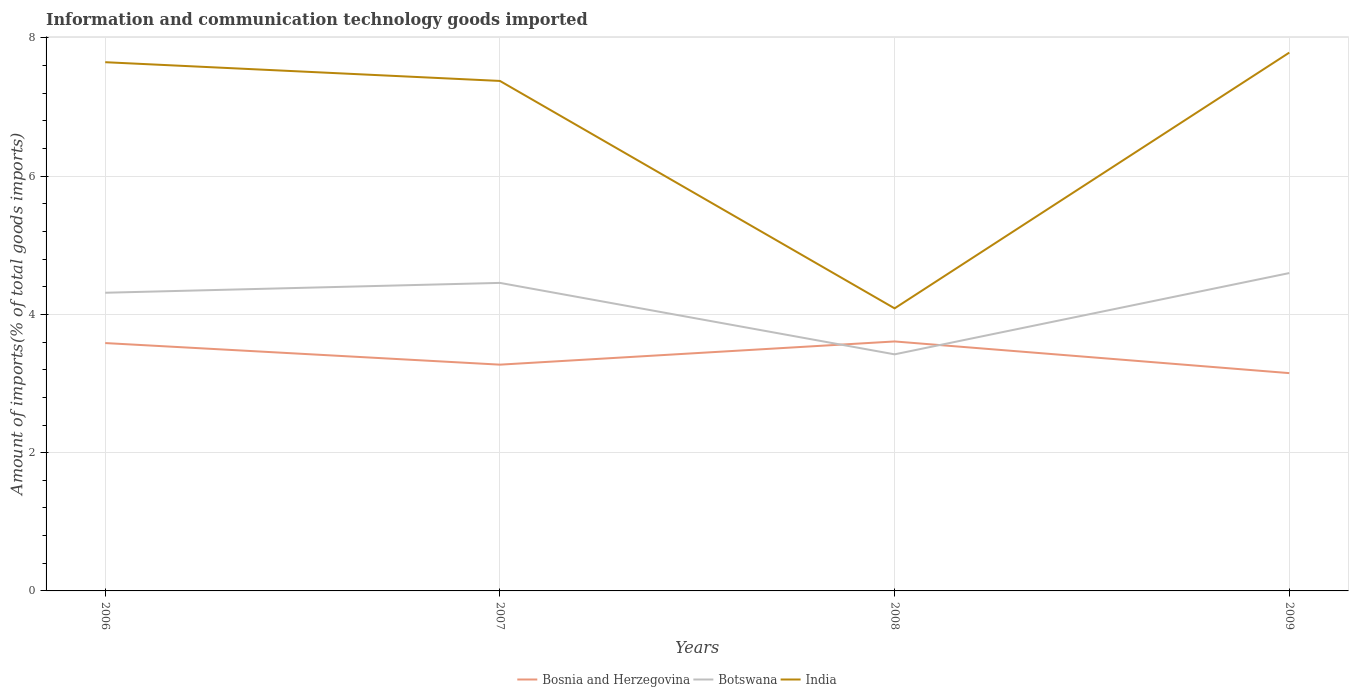How many different coloured lines are there?
Your response must be concise. 3. Is the number of lines equal to the number of legend labels?
Your answer should be compact. Yes. Across all years, what is the maximum amount of goods imported in India?
Ensure brevity in your answer.  4.09. What is the total amount of goods imported in India in the graph?
Make the answer very short. -0.14. What is the difference between the highest and the second highest amount of goods imported in Botswana?
Give a very brief answer. 1.18. Is the amount of goods imported in Botswana strictly greater than the amount of goods imported in Bosnia and Herzegovina over the years?
Make the answer very short. No. How many years are there in the graph?
Keep it short and to the point. 4. Are the values on the major ticks of Y-axis written in scientific E-notation?
Offer a very short reply. No. Does the graph contain grids?
Ensure brevity in your answer.  Yes. Where does the legend appear in the graph?
Your answer should be compact. Bottom center. How are the legend labels stacked?
Keep it short and to the point. Horizontal. What is the title of the graph?
Provide a succinct answer. Information and communication technology goods imported. What is the label or title of the Y-axis?
Ensure brevity in your answer.  Amount of imports(% of total goods imports). What is the Amount of imports(% of total goods imports) in Bosnia and Herzegovina in 2006?
Ensure brevity in your answer.  3.59. What is the Amount of imports(% of total goods imports) in Botswana in 2006?
Make the answer very short. 4.31. What is the Amount of imports(% of total goods imports) of India in 2006?
Provide a succinct answer. 7.65. What is the Amount of imports(% of total goods imports) of Bosnia and Herzegovina in 2007?
Your response must be concise. 3.27. What is the Amount of imports(% of total goods imports) of Botswana in 2007?
Your answer should be very brief. 4.46. What is the Amount of imports(% of total goods imports) of India in 2007?
Offer a terse response. 7.38. What is the Amount of imports(% of total goods imports) in Bosnia and Herzegovina in 2008?
Keep it short and to the point. 3.61. What is the Amount of imports(% of total goods imports) in Botswana in 2008?
Your answer should be very brief. 3.42. What is the Amount of imports(% of total goods imports) of India in 2008?
Keep it short and to the point. 4.09. What is the Amount of imports(% of total goods imports) of Bosnia and Herzegovina in 2009?
Your answer should be compact. 3.15. What is the Amount of imports(% of total goods imports) of Botswana in 2009?
Your answer should be compact. 4.6. What is the Amount of imports(% of total goods imports) of India in 2009?
Make the answer very short. 7.79. Across all years, what is the maximum Amount of imports(% of total goods imports) of Bosnia and Herzegovina?
Ensure brevity in your answer.  3.61. Across all years, what is the maximum Amount of imports(% of total goods imports) in Botswana?
Give a very brief answer. 4.6. Across all years, what is the maximum Amount of imports(% of total goods imports) in India?
Give a very brief answer. 7.79. Across all years, what is the minimum Amount of imports(% of total goods imports) in Bosnia and Herzegovina?
Your response must be concise. 3.15. Across all years, what is the minimum Amount of imports(% of total goods imports) in Botswana?
Provide a succinct answer. 3.42. Across all years, what is the minimum Amount of imports(% of total goods imports) of India?
Keep it short and to the point. 4.09. What is the total Amount of imports(% of total goods imports) in Bosnia and Herzegovina in the graph?
Your response must be concise. 13.62. What is the total Amount of imports(% of total goods imports) of Botswana in the graph?
Ensure brevity in your answer.  16.79. What is the total Amount of imports(% of total goods imports) in India in the graph?
Ensure brevity in your answer.  26.91. What is the difference between the Amount of imports(% of total goods imports) of Bosnia and Herzegovina in 2006 and that in 2007?
Provide a succinct answer. 0.31. What is the difference between the Amount of imports(% of total goods imports) in Botswana in 2006 and that in 2007?
Give a very brief answer. -0.14. What is the difference between the Amount of imports(% of total goods imports) of India in 2006 and that in 2007?
Give a very brief answer. 0.27. What is the difference between the Amount of imports(% of total goods imports) of Bosnia and Herzegovina in 2006 and that in 2008?
Keep it short and to the point. -0.02. What is the difference between the Amount of imports(% of total goods imports) of Botswana in 2006 and that in 2008?
Provide a short and direct response. 0.89. What is the difference between the Amount of imports(% of total goods imports) in India in 2006 and that in 2008?
Your answer should be compact. 3.56. What is the difference between the Amount of imports(% of total goods imports) of Bosnia and Herzegovina in 2006 and that in 2009?
Offer a very short reply. 0.43. What is the difference between the Amount of imports(% of total goods imports) of Botswana in 2006 and that in 2009?
Your response must be concise. -0.28. What is the difference between the Amount of imports(% of total goods imports) of India in 2006 and that in 2009?
Your answer should be compact. -0.14. What is the difference between the Amount of imports(% of total goods imports) of Bosnia and Herzegovina in 2007 and that in 2008?
Provide a short and direct response. -0.34. What is the difference between the Amount of imports(% of total goods imports) of Botswana in 2007 and that in 2008?
Make the answer very short. 1.03. What is the difference between the Amount of imports(% of total goods imports) in India in 2007 and that in 2008?
Ensure brevity in your answer.  3.29. What is the difference between the Amount of imports(% of total goods imports) in Bosnia and Herzegovina in 2007 and that in 2009?
Offer a terse response. 0.12. What is the difference between the Amount of imports(% of total goods imports) of Botswana in 2007 and that in 2009?
Provide a succinct answer. -0.14. What is the difference between the Amount of imports(% of total goods imports) of India in 2007 and that in 2009?
Keep it short and to the point. -0.41. What is the difference between the Amount of imports(% of total goods imports) of Bosnia and Herzegovina in 2008 and that in 2009?
Your answer should be very brief. 0.46. What is the difference between the Amount of imports(% of total goods imports) in Botswana in 2008 and that in 2009?
Provide a short and direct response. -1.18. What is the difference between the Amount of imports(% of total goods imports) in India in 2008 and that in 2009?
Give a very brief answer. -3.7. What is the difference between the Amount of imports(% of total goods imports) of Bosnia and Herzegovina in 2006 and the Amount of imports(% of total goods imports) of Botswana in 2007?
Your response must be concise. -0.87. What is the difference between the Amount of imports(% of total goods imports) in Bosnia and Herzegovina in 2006 and the Amount of imports(% of total goods imports) in India in 2007?
Provide a short and direct response. -3.79. What is the difference between the Amount of imports(% of total goods imports) of Botswana in 2006 and the Amount of imports(% of total goods imports) of India in 2007?
Your response must be concise. -3.06. What is the difference between the Amount of imports(% of total goods imports) of Bosnia and Herzegovina in 2006 and the Amount of imports(% of total goods imports) of Botswana in 2008?
Your answer should be compact. 0.16. What is the difference between the Amount of imports(% of total goods imports) in Bosnia and Herzegovina in 2006 and the Amount of imports(% of total goods imports) in India in 2008?
Your answer should be compact. -0.5. What is the difference between the Amount of imports(% of total goods imports) of Botswana in 2006 and the Amount of imports(% of total goods imports) of India in 2008?
Provide a succinct answer. 0.23. What is the difference between the Amount of imports(% of total goods imports) in Bosnia and Herzegovina in 2006 and the Amount of imports(% of total goods imports) in Botswana in 2009?
Provide a short and direct response. -1.01. What is the difference between the Amount of imports(% of total goods imports) of Bosnia and Herzegovina in 2006 and the Amount of imports(% of total goods imports) of India in 2009?
Your answer should be very brief. -4.2. What is the difference between the Amount of imports(% of total goods imports) in Botswana in 2006 and the Amount of imports(% of total goods imports) in India in 2009?
Ensure brevity in your answer.  -3.47. What is the difference between the Amount of imports(% of total goods imports) of Bosnia and Herzegovina in 2007 and the Amount of imports(% of total goods imports) of Botswana in 2008?
Keep it short and to the point. -0.15. What is the difference between the Amount of imports(% of total goods imports) in Bosnia and Herzegovina in 2007 and the Amount of imports(% of total goods imports) in India in 2008?
Ensure brevity in your answer.  -0.81. What is the difference between the Amount of imports(% of total goods imports) of Botswana in 2007 and the Amount of imports(% of total goods imports) of India in 2008?
Ensure brevity in your answer.  0.37. What is the difference between the Amount of imports(% of total goods imports) of Bosnia and Herzegovina in 2007 and the Amount of imports(% of total goods imports) of Botswana in 2009?
Keep it short and to the point. -1.33. What is the difference between the Amount of imports(% of total goods imports) of Bosnia and Herzegovina in 2007 and the Amount of imports(% of total goods imports) of India in 2009?
Offer a very short reply. -4.51. What is the difference between the Amount of imports(% of total goods imports) in Botswana in 2007 and the Amount of imports(% of total goods imports) in India in 2009?
Your answer should be very brief. -3.33. What is the difference between the Amount of imports(% of total goods imports) of Bosnia and Herzegovina in 2008 and the Amount of imports(% of total goods imports) of Botswana in 2009?
Provide a succinct answer. -0.99. What is the difference between the Amount of imports(% of total goods imports) in Bosnia and Herzegovina in 2008 and the Amount of imports(% of total goods imports) in India in 2009?
Provide a succinct answer. -4.18. What is the difference between the Amount of imports(% of total goods imports) of Botswana in 2008 and the Amount of imports(% of total goods imports) of India in 2009?
Give a very brief answer. -4.37. What is the average Amount of imports(% of total goods imports) in Bosnia and Herzegovina per year?
Offer a terse response. 3.41. What is the average Amount of imports(% of total goods imports) of Botswana per year?
Give a very brief answer. 4.2. What is the average Amount of imports(% of total goods imports) of India per year?
Keep it short and to the point. 6.73. In the year 2006, what is the difference between the Amount of imports(% of total goods imports) in Bosnia and Herzegovina and Amount of imports(% of total goods imports) in Botswana?
Provide a short and direct response. -0.73. In the year 2006, what is the difference between the Amount of imports(% of total goods imports) in Bosnia and Herzegovina and Amount of imports(% of total goods imports) in India?
Keep it short and to the point. -4.06. In the year 2006, what is the difference between the Amount of imports(% of total goods imports) in Botswana and Amount of imports(% of total goods imports) in India?
Ensure brevity in your answer.  -3.34. In the year 2007, what is the difference between the Amount of imports(% of total goods imports) in Bosnia and Herzegovina and Amount of imports(% of total goods imports) in Botswana?
Your answer should be compact. -1.18. In the year 2007, what is the difference between the Amount of imports(% of total goods imports) of Bosnia and Herzegovina and Amount of imports(% of total goods imports) of India?
Give a very brief answer. -4.11. In the year 2007, what is the difference between the Amount of imports(% of total goods imports) of Botswana and Amount of imports(% of total goods imports) of India?
Ensure brevity in your answer.  -2.92. In the year 2008, what is the difference between the Amount of imports(% of total goods imports) of Bosnia and Herzegovina and Amount of imports(% of total goods imports) of Botswana?
Offer a terse response. 0.19. In the year 2008, what is the difference between the Amount of imports(% of total goods imports) in Bosnia and Herzegovina and Amount of imports(% of total goods imports) in India?
Offer a terse response. -0.48. In the year 2008, what is the difference between the Amount of imports(% of total goods imports) in Botswana and Amount of imports(% of total goods imports) in India?
Your answer should be compact. -0.67. In the year 2009, what is the difference between the Amount of imports(% of total goods imports) in Bosnia and Herzegovina and Amount of imports(% of total goods imports) in Botswana?
Your answer should be compact. -1.45. In the year 2009, what is the difference between the Amount of imports(% of total goods imports) of Bosnia and Herzegovina and Amount of imports(% of total goods imports) of India?
Your answer should be compact. -4.64. In the year 2009, what is the difference between the Amount of imports(% of total goods imports) in Botswana and Amount of imports(% of total goods imports) in India?
Give a very brief answer. -3.19. What is the ratio of the Amount of imports(% of total goods imports) of Bosnia and Herzegovina in 2006 to that in 2007?
Ensure brevity in your answer.  1.1. What is the ratio of the Amount of imports(% of total goods imports) of Botswana in 2006 to that in 2007?
Ensure brevity in your answer.  0.97. What is the ratio of the Amount of imports(% of total goods imports) of India in 2006 to that in 2007?
Offer a terse response. 1.04. What is the ratio of the Amount of imports(% of total goods imports) in Bosnia and Herzegovina in 2006 to that in 2008?
Offer a very short reply. 0.99. What is the ratio of the Amount of imports(% of total goods imports) in Botswana in 2006 to that in 2008?
Ensure brevity in your answer.  1.26. What is the ratio of the Amount of imports(% of total goods imports) of India in 2006 to that in 2008?
Your response must be concise. 1.87. What is the ratio of the Amount of imports(% of total goods imports) in Bosnia and Herzegovina in 2006 to that in 2009?
Offer a very short reply. 1.14. What is the ratio of the Amount of imports(% of total goods imports) of Botswana in 2006 to that in 2009?
Provide a succinct answer. 0.94. What is the ratio of the Amount of imports(% of total goods imports) in India in 2006 to that in 2009?
Your response must be concise. 0.98. What is the ratio of the Amount of imports(% of total goods imports) of Bosnia and Herzegovina in 2007 to that in 2008?
Keep it short and to the point. 0.91. What is the ratio of the Amount of imports(% of total goods imports) in Botswana in 2007 to that in 2008?
Offer a terse response. 1.3. What is the ratio of the Amount of imports(% of total goods imports) in India in 2007 to that in 2008?
Provide a short and direct response. 1.8. What is the ratio of the Amount of imports(% of total goods imports) of Bosnia and Herzegovina in 2007 to that in 2009?
Provide a short and direct response. 1.04. What is the ratio of the Amount of imports(% of total goods imports) in Botswana in 2007 to that in 2009?
Your response must be concise. 0.97. What is the ratio of the Amount of imports(% of total goods imports) of Bosnia and Herzegovina in 2008 to that in 2009?
Offer a terse response. 1.15. What is the ratio of the Amount of imports(% of total goods imports) of Botswana in 2008 to that in 2009?
Your response must be concise. 0.74. What is the ratio of the Amount of imports(% of total goods imports) of India in 2008 to that in 2009?
Provide a succinct answer. 0.52. What is the difference between the highest and the second highest Amount of imports(% of total goods imports) of Bosnia and Herzegovina?
Ensure brevity in your answer.  0.02. What is the difference between the highest and the second highest Amount of imports(% of total goods imports) in Botswana?
Provide a succinct answer. 0.14. What is the difference between the highest and the second highest Amount of imports(% of total goods imports) in India?
Provide a short and direct response. 0.14. What is the difference between the highest and the lowest Amount of imports(% of total goods imports) in Bosnia and Herzegovina?
Make the answer very short. 0.46. What is the difference between the highest and the lowest Amount of imports(% of total goods imports) in Botswana?
Make the answer very short. 1.18. What is the difference between the highest and the lowest Amount of imports(% of total goods imports) of India?
Offer a very short reply. 3.7. 